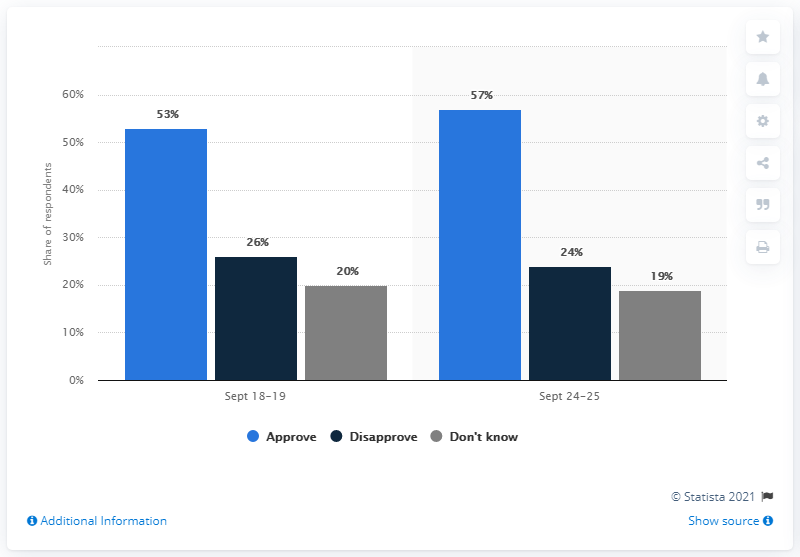Identify some key points in this picture. The color light blue represents approval. The average of those who disapprove is 25. 